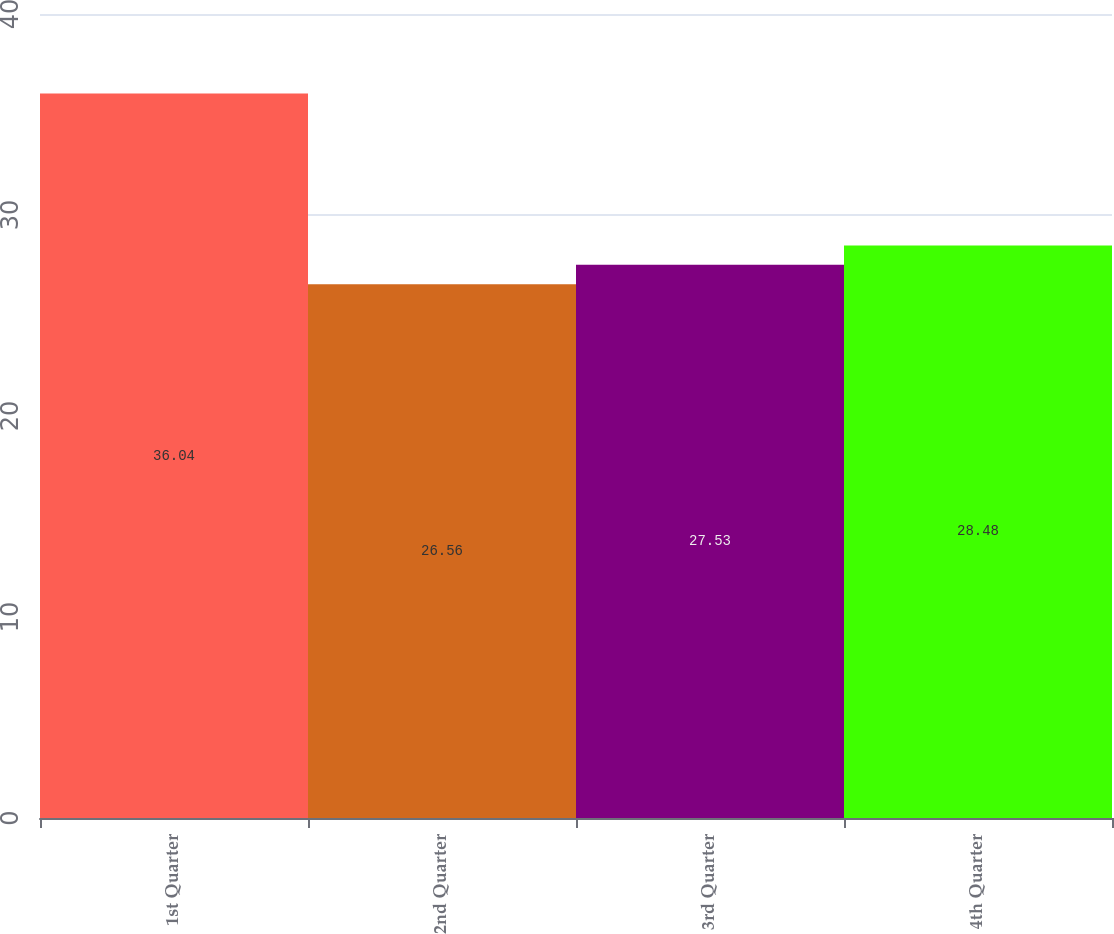Convert chart to OTSL. <chart><loc_0><loc_0><loc_500><loc_500><bar_chart><fcel>1st Quarter<fcel>2nd Quarter<fcel>3rd Quarter<fcel>4th Quarter<nl><fcel>36.04<fcel>26.56<fcel>27.53<fcel>28.48<nl></chart> 